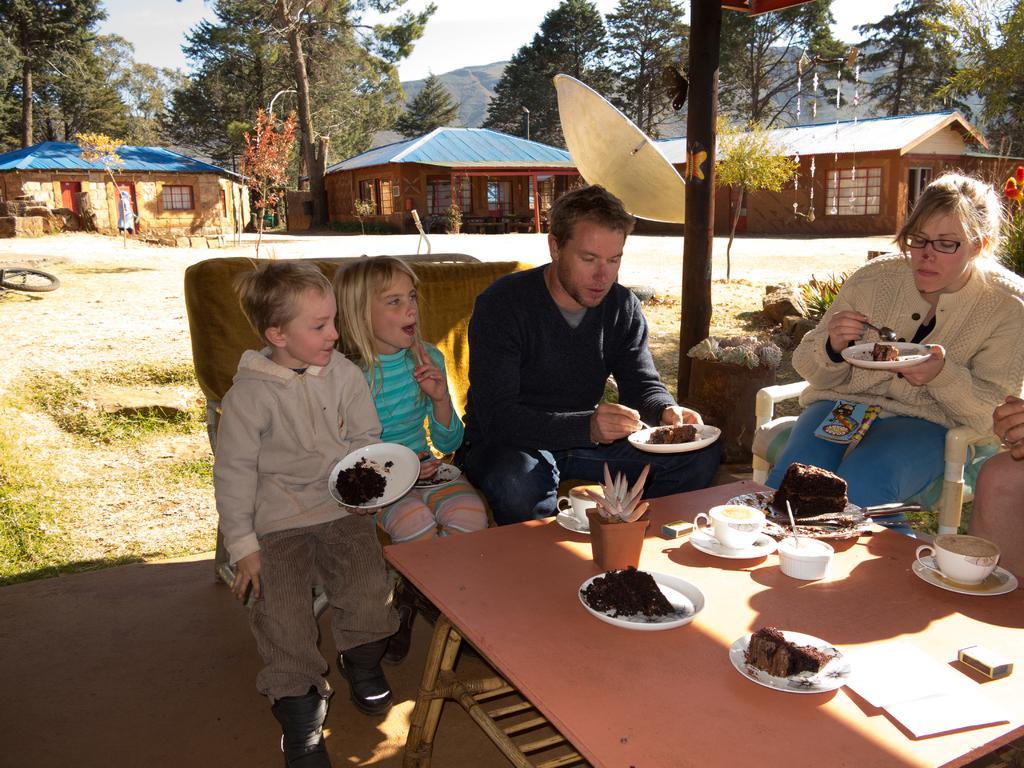Can you describe this image briefly? In the middle of the picture, we see four people sitting on chair in front of table on which plate containing food, cup, saucer, flower pot, spoon, cake, knife, book and match matchbox are placed. Behind these people, we see houses with blue roof blue color roof and behind that, we see trees and sky. 